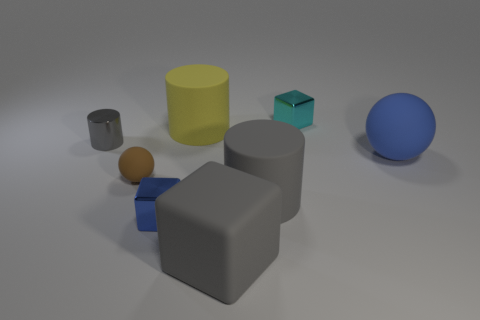Subtract all small cyan metallic blocks. How many blocks are left? 2 Subtract all brown spheres. How many gray cylinders are left? 2 Add 1 blue spheres. How many objects exist? 9 Subtract all gray cubes. How many cubes are left? 2 Subtract all cubes. How many objects are left? 5 Add 6 matte blocks. How many matte blocks exist? 7 Subtract 0 green blocks. How many objects are left? 8 Subtract all brown cylinders. Subtract all green blocks. How many cylinders are left? 3 Subtract all brown matte balls. Subtract all blue metal balls. How many objects are left? 7 Add 6 tiny blue blocks. How many tiny blue blocks are left? 7 